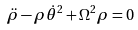<formula> <loc_0><loc_0><loc_500><loc_500>\ddot { \rho } - \rho { \dot { \theta } } ^ { 2 } + \Omega ^ { 2 } \rho = 0</formula> 